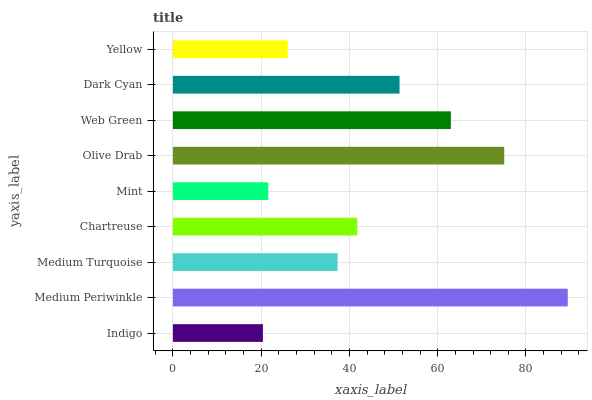Is Indigo the minimum?
Answer yes or no. Yes. Is Medium Periwinkle the maximum?
Answer yes or no. Yes. Is Medium Turquoise the minimum?
Answer yes or no. No. Is Medium Turquoise the maximum?
Answer yes or no. No. Is Medium Periwinkle greater than Medium Turquoise?
Answer yes or no. Yes. Is Medium Turquoise less than Medium Periwinkle?
Answer yes or no. Yes. Is Medium Turquoise greater than Medium Periwinkle?
Answer yes or no. No. Is Medium Periwinkle less than Medium Turquoise?
Answer yes or no. No. Is Chartreuse the high median?
Answer yes or no. Yes. Is Chartreuse the low median?
Answer yes or no. Yes. Is Olive Drab the high median?
Answer yes or no. No. Is Medium Turquoise the low median?
Answer yes or no. No. 